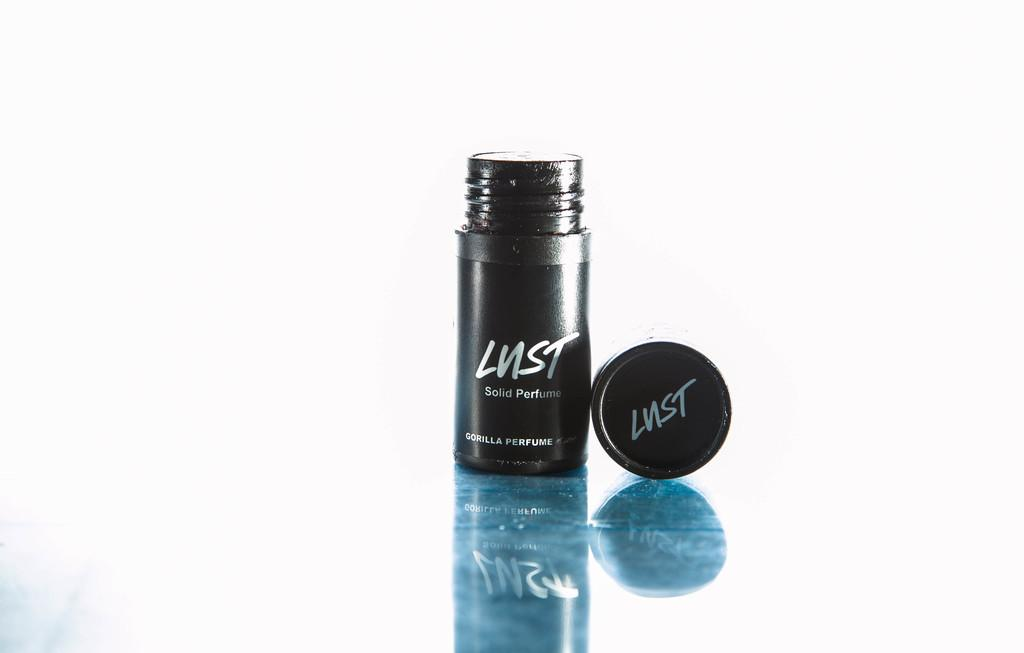Provide a one-sentence caption for the provided image. A small container of perfume is from the Lust brand. 